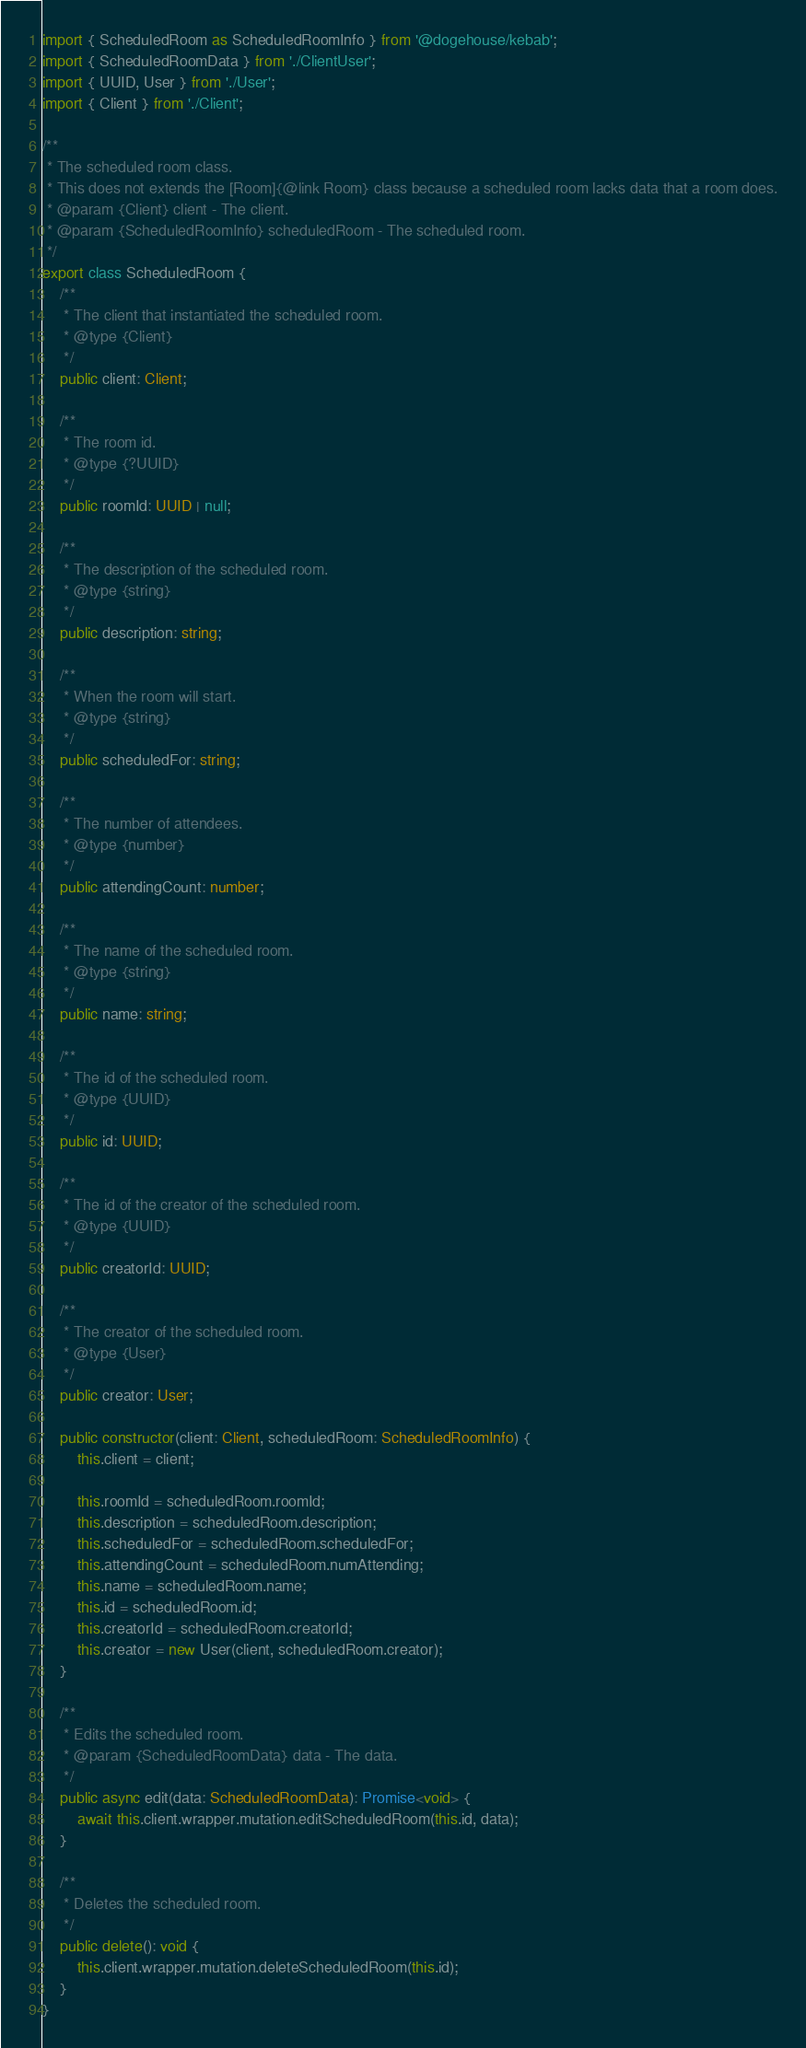Convert code to text. <code><loc_0><loc_0><loc_500><loc_500><_TypeScript_>import { ScheduledRoom as ScheduledRoomInfo } from '@dogehouse/kebab';
import { ScheduledRoomData } from './ClientUser';
import { UUID, User } from './User';
import { Client } from './Client';

/**
 * The scheduled room class.
 * This does not extends the [Room]{@link Room} class because a scheduled room lacks data that a room does.
 * @param {Client} client - The client.
 * @param {ScheduledRoomInfo} scheduledRoom - The scheduled room.
 */
export class ScheduledRoom {
	/**
	 * The client that instantiated the scheduled room.
	 * @type {Client}
	 */
	public client: Client;

	/**
	 * The room id.
	 * @type {?UUID}
	 */
	public roomId: UUID | null;

	/**
	 * The description of the scheduled room.
	 * @type {string}
	 */
	public description: string;

	/**
	 * When the room will start.
	 * @type {string}
	 */
	public scheduledFor: string;

	/**
	 * The number of attendees.
	 * @type {number}
	 */
	public attendingCount: number;

	/**
	 * The name of the scheduled room.
	 * @type {string}
	 */
	public name: string;

	/**
	 * The id of the scheduled room.
	 * @type {UUID}
	 */
	public id: UUID;

	/**
	 * The id of the creator of the scheduled room.
	 * @type {UUID}
	 */
	public creatorId: UUID;

	/**
	 * The creator of the scheduled room.
	 * @type {User}
	 */
	public creator: User;

	public constructor(client: Client, scheduledRoom: ScheduledRoomInfo) {
		this.client = client;

		this.roomId = scheduledRoom.roomId;
		this.description = scheduledRoom.description;
		this.scheduledFor = scheduledRoom.scheduledFor;
		this.attendingCount = scheduledRoom.numAttending;
		this.name = scheduledRoom.name;
		this.id = scheduledRoom.id;
		this.creatorId = scheduledRoom.creatorId;
		this.creator = new User(client, scheduledRoom.creator);
	}

	/**
	 * Edits the scheduled room.
	 * @param {ScheduledRoomData} data - The data.
	 */
	public async edit(data: ScheduledRoomData): Promise<void> {
		await this.client.wrapper.mutation.editScheduledRoom(this.id, data);
	}

	/**
	 * Deletes the scheduled room.
	 */
	public delete(): void {
		this.client.wrapper.mutation.deleteScheduledRoom(this.id);
	}
}
</code> 